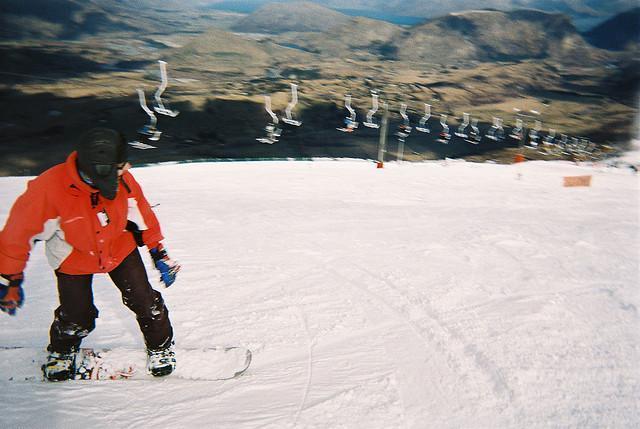How many snowboarders have boards?
Give a very brief answer. 1. 